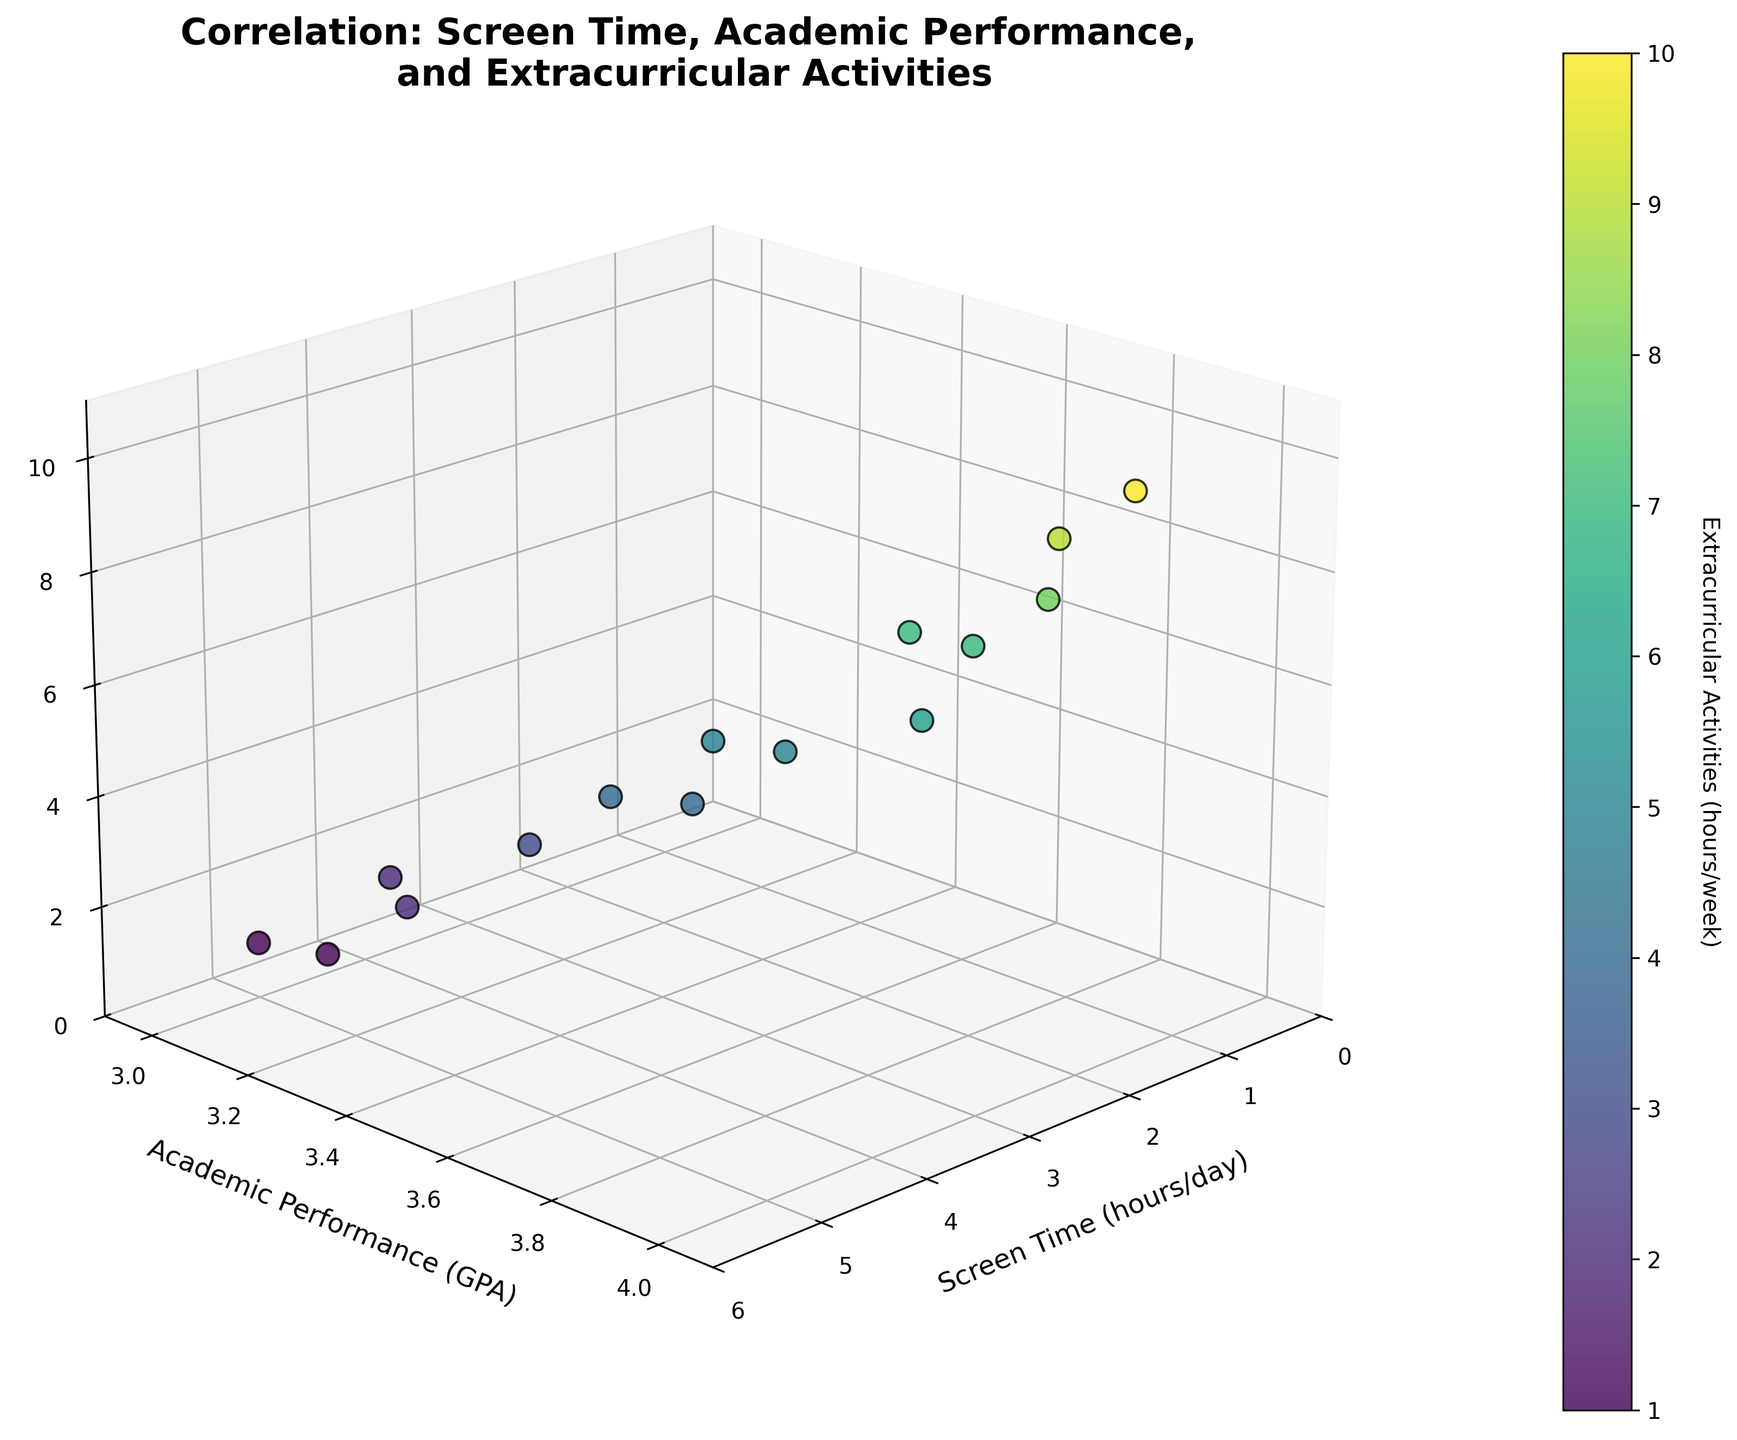what is the title of the plot? The title of the plot is visible at the top of the figure. It reads "Correlation: Screen Time, Academic Performance, \nand Extracurricular Activities"
Answer: "Correlation: Screen Time, Academic Performance, \nand Extracurricular Activities" How many data points are plotted on the graph? The data points are depicted by the markers in the 3D scatter plot. Counting the markers gives us the total number of data points.
Answer: 15 Which axis represents academic performance? The axes are labeled to indicate what they measure. The y-axis is labeled ‘Academic Performance (GPA)’.
Answer: y-axis What color signifies a student who spends the most hours on extracurricular activities? The color bar on the right indicates the correspondence between colors and extracurricular hours. The highest value corresponds to the color at the top of the bar, which is yellow-green.
Answer: yellow-green Does any student spending the least screen time also have a perfect GPA? Look for the lowest point on the screen time axis and check the corresponding GPA value. The student spending 1.5 hours/day on the screen has a GPA of 4.0.
Answer: Yes What is the general trend between screen time and academic performance visible in the plot? Visually inspect the plot for any patterns where the GPA may be increasing or decreasing with an increase in screen time. Generally, GPA decreases as screen time increases.
Answer: GPA decreases as screen time increases What is the screen time for the student who spends 8 hours per week on extracurricular activities? Find the point on the plot where the z-axis value is 8 and then check the corresponding x-axis value. The student with 8 extracurricular hours has a screen time of 1.8 hours/day.
Answer: 1.8 hours/day How does the student with 3.0 GPA fare in extracurricular activities compared to others? Find the data points with a GPA of 3.0 and observe the corresponding extracurricular activity hours. The student with 3.0 GPA spends 1 hour/week on extracurriculars, which is lower than most students.
Answer: Lower than most Which student has the highest combination of GPA and extracurricular hours? Look for the maximum value on both the GPA and extracurricular activities axes. The student with the highest combined value has a GPA of 4.0 and spends 10 hours/week on extracurricular activities.
Answer: GPA 4.0 and 10 hours/week Is there a stronger correlation between screen time and GPA or between GPA and extracurricular activities? Observe the clustering and spread of data points with respect to their axes to determine correlation strength. GPA shows a clearer trend against screen time.
Answer: Screen time and GPA 